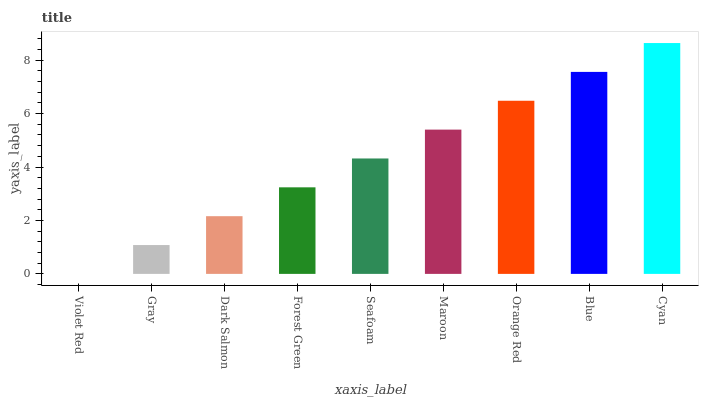Is Gray the minimum?
Answer yes or no. No. Is Gray the maximum?
Answer yes or no. No. Is Gray greater than Violet Red?
Answer yes or no. Yes. Is Violet Red less than Gray?
Answer yes or no. Yes. Is Violet Red greater than Gray?
Answer yes or no. No. Is Gray less than Violet Red?
Answer yes or no. No. Is Seafoam the high median?
Answer yes or no. Yes. Is Seafoam the low median?
Answer yes or no. Yes. Is Maroon the high median?
Answer yes or no. No. Is Forest Green the low median?
Answer yes or no. No. 